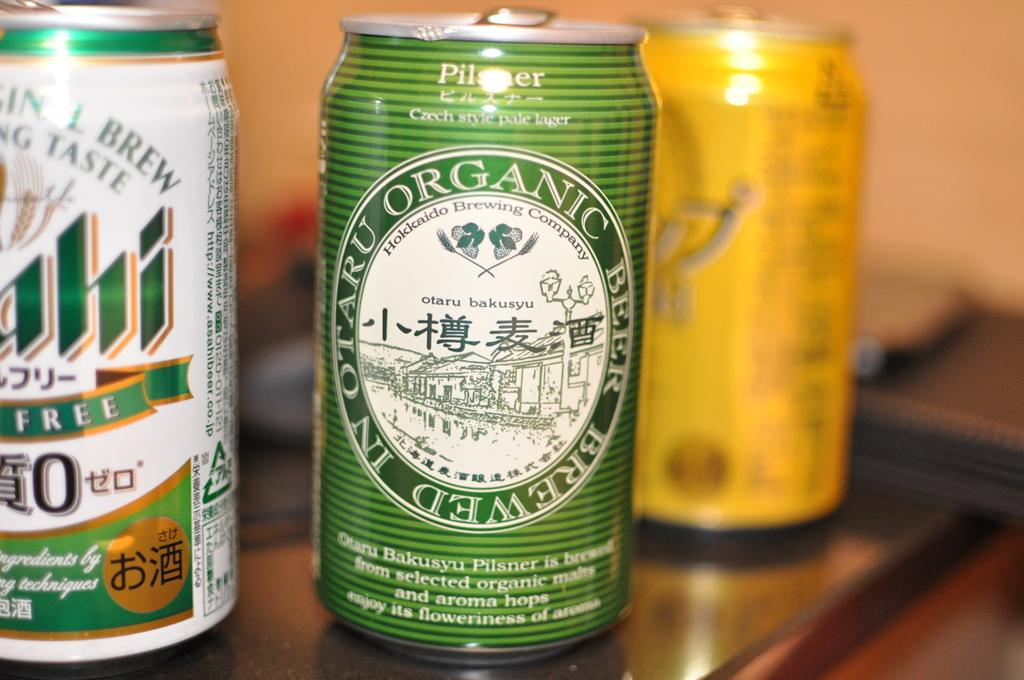<image>
Provide a brief description of the given image. The beer in the green can is organic and brewed in Otaru. 